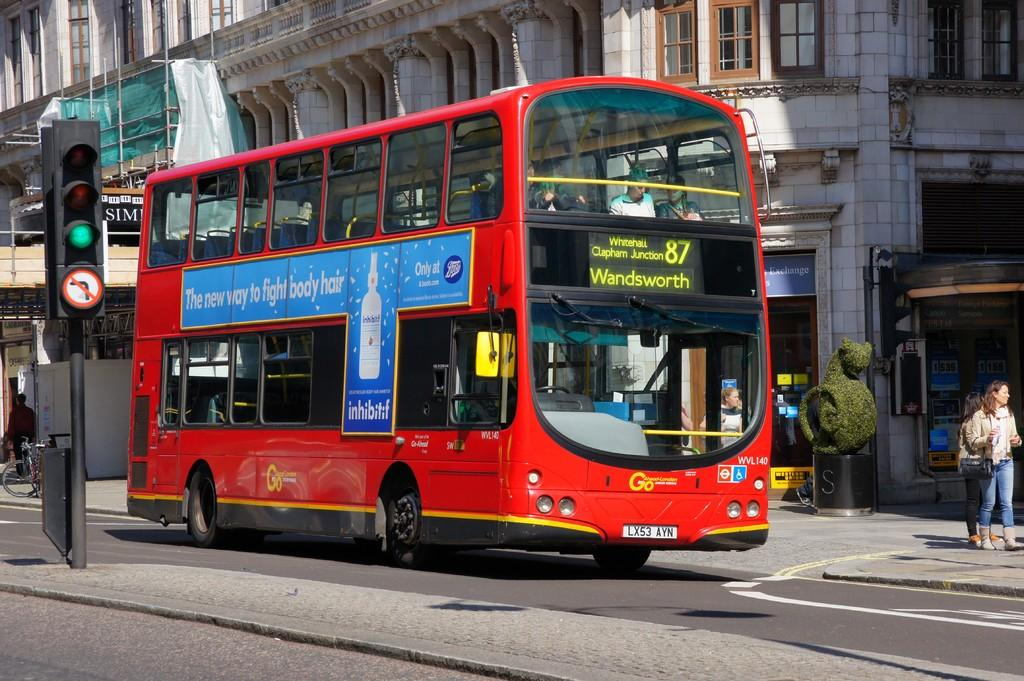What is on the road in the image? There is a vehicle on the road in the image. What can be seen through the windows in the image? The windows in the image are not specified, but there are windows visible. What structures are present in the image? There are poles, lights, shops, a building, and a bicycle in the image. Who or what is present in the image? There are people in the image. What type of berry can be seen growing on the table in the image? There is no table or berry present in the image. Is there a baseball game happening in the image? There is no indication of a baseball game or any sports activity in the image. 